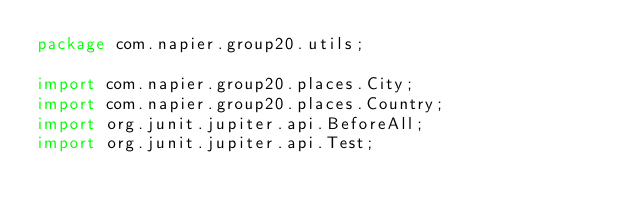Convert code to text. <code><loc_0><loc_0><loc_500><loc_500><_Java_>package com.napier.group20.utils;

import com.napier.group20.places.City;
import com.napier.group20.places.Country;
import org.junit.jupiter.api.BeforeAll;
import org.junit.jupiter.api.Test;
</code> 